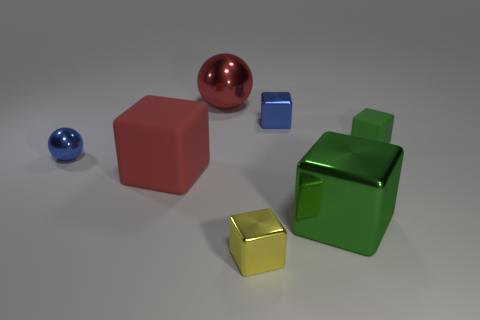What material is the blue thing that is the same size as the blue block? The blue object that matches the size of the blue block is not discernible as metal from the image alone. It appears to have a reflective surface similar to the blue block, which could suggest a polished material, possibly a synthetic or coated object. 